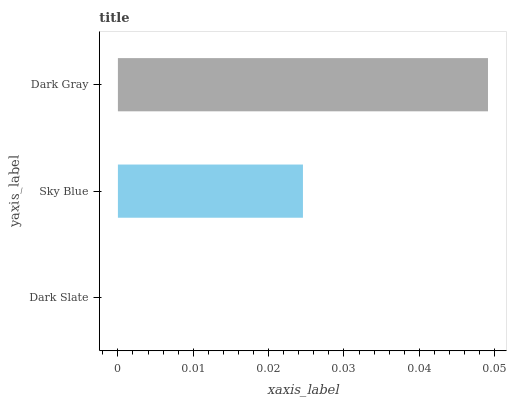Is Dark Slate the minimum?
Answer yes or no. Yes. Is Dark Gray the maximum?
Answer yes or no. Yes. Is Sky Blue the minimum?
Answer yes or no. No. Is Sky Blue the maximum?
Answer yes or no. No. Is Sky Blue greater than Dark Slate?
Answer yes or no. Yes. Is Dark Slate less than Sky Blue?
Answer yes or no. Yes. Is Dark Slate greater than Sky Blue?
Answer yes or no. No. Is Sky Blue less than Dark Slate?
Answer yes or no. No. Is Sky Blue the high median?
Answer yes or no. Yes. Is Sky Blue the low median?
Answer yes or no. Yes. Is Dark Gray the high median?
Answer yes or no. No. Is Dark Slate the low median?
Answer yes or no. No. 